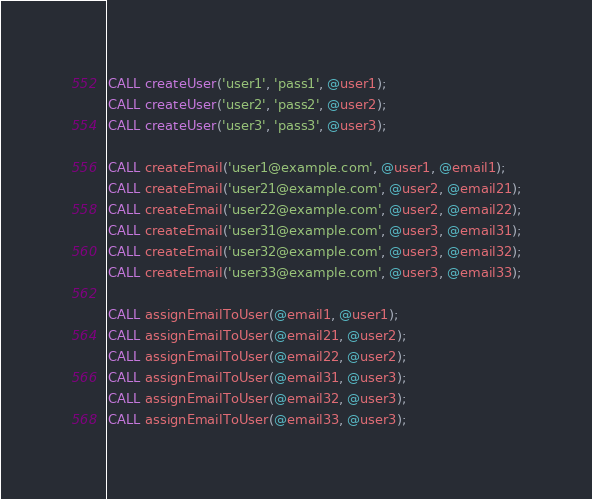Convert code to text. <code><loc_0><loc_0><loc_500><loc_500><_SQL_>CALL createUser('user1', 'pass1', @user1);
CALL createUser('user2', 'pass2', @user2);
CALL createUser('user3', 'pass3', @user3);

CALL createEmail('user1@example.com', @user1, @email1);
CALL createEmail('user21@example.com', @user2, @email21);
CALL createEmail('user22@example.com', @user2, @email22);
CALL createEmail('user31@example.com', @user3, @email31);
CALL createEmail('user32@example.com', @user3, @email32);
CALL createEmail('user33@example.com', @user3, @email33);

CALL assignEmailToUser(@email1, @user1);
CALL assignEmailToUser(@email21, @user2);
CALL assignEmailToUser(@email22, @user2);
CALL assignEmailToUser(@email31, @user3);
CALL assignEmailToUser(@email32, @user3);
CALL assignEmailToUser(@email33, @user3);</code> 